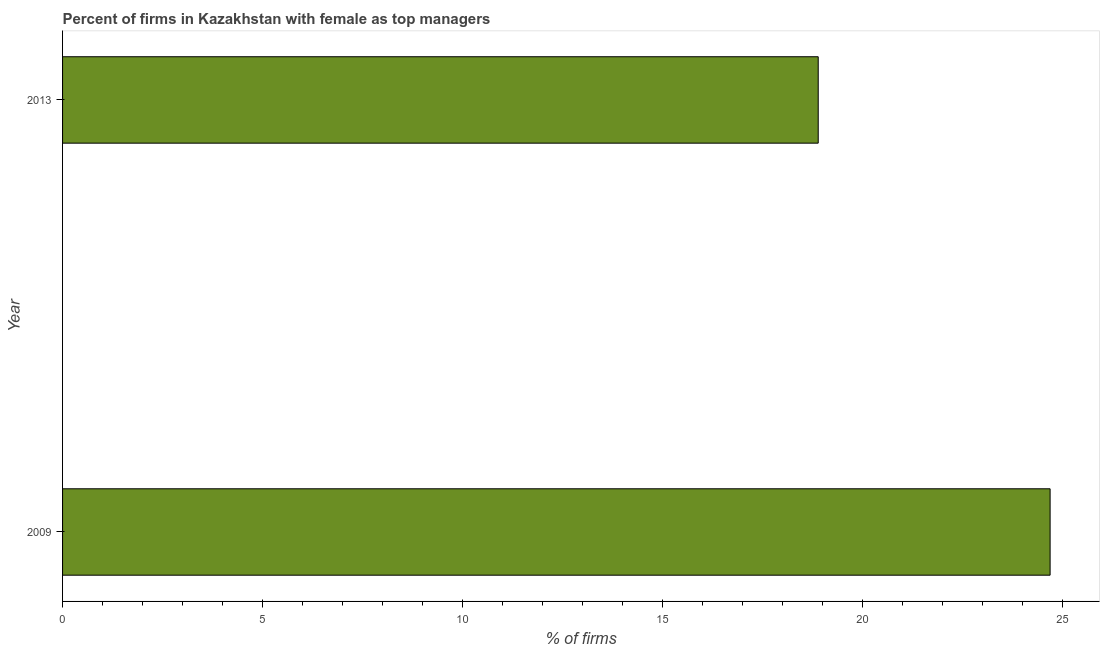Does the graph contain grids?
Your response must be concise. No. What is the title of the graph?
Provide a short and direct response. Percent of firms in Kazakhstan with female as top managers. What is the label or title of the X-axis?
Offer a terse response. % of firms. What is the percentage of firms with female as top manager in 2009?
Make the answer very short. 24.7. Across all years, what is the maximum percentage of firms with female as top manager?
Provide a short and direct response. 24.7. In which year was the percentage of firms with female as top manager minimum?
Provide a short and direct response. 2013. What is the sum of the percentage of firms with female as top manager?
Provide a short and direct response. 43.6. What is the average percentage of firms with female as top manager per year?
Offer a terse response. 21.8. What is the median percentage of firms with female as top manager?
Your answer should be very brief. 21.8. In how many years, is the percentage of firms with female as top manager greater than 18 %?
Offer a terse response. 2. What is the ratio of the percentage of firms with female as top manager in 2009 to that in 2013?
Provide a short and direct response. 1.31. Is the percentage of firms with female as top manager in 2009 less than that in 2013?
Keep it short and to the point. No. In how many years, is the percentage of firms with female as top manager greater than the average percentage of firms with female as top manager taken over all years?
Give a very brief answer. 1. What is the % of firms of 2009?
Your answer should be very brief. 24.7. What is the % of firms of 2013?
Give a very brief answer. 18.9. What is the difference between the % of firms in 2009 and 2013?
Your response must be concise. 5.8. What is the ratio of the % of firms in 2009 to that in 2013?
Provide a succinct answer. 1.31. 